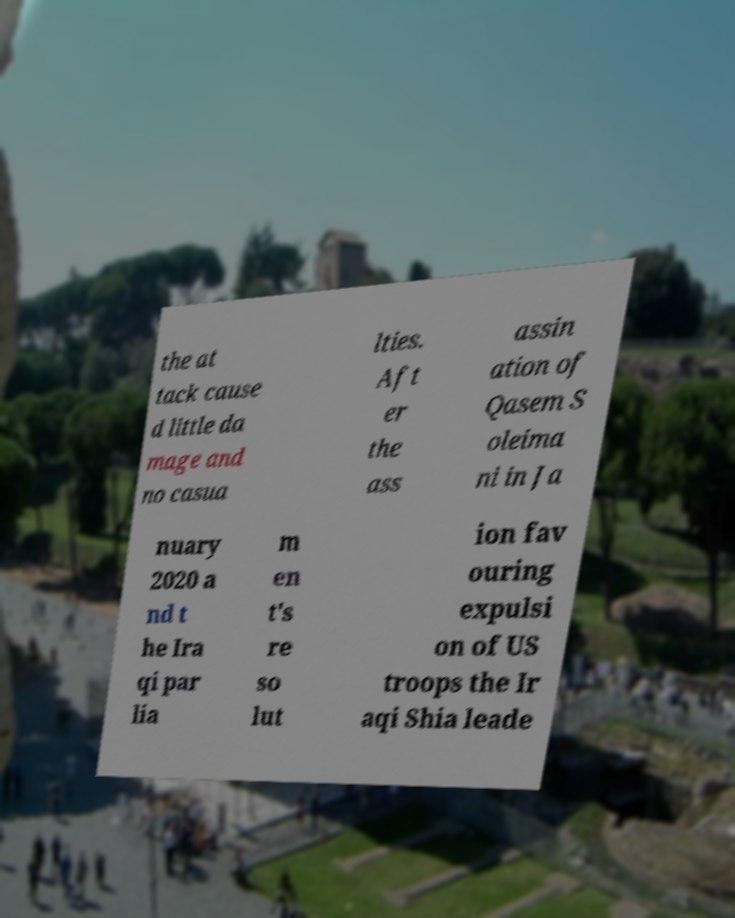There's text embedded in this image that I need extracted. Can you transcribe it verbatim? the at tack cause d little da mage and no casua lties. Aft er the ass assin ation of Qasem S oleima ni in Ja nuary 2020 a nd t he Ira qi par lia m en t's re so lut ion fav ouring expulsi on of US troops the Ir aqi Shia leade 